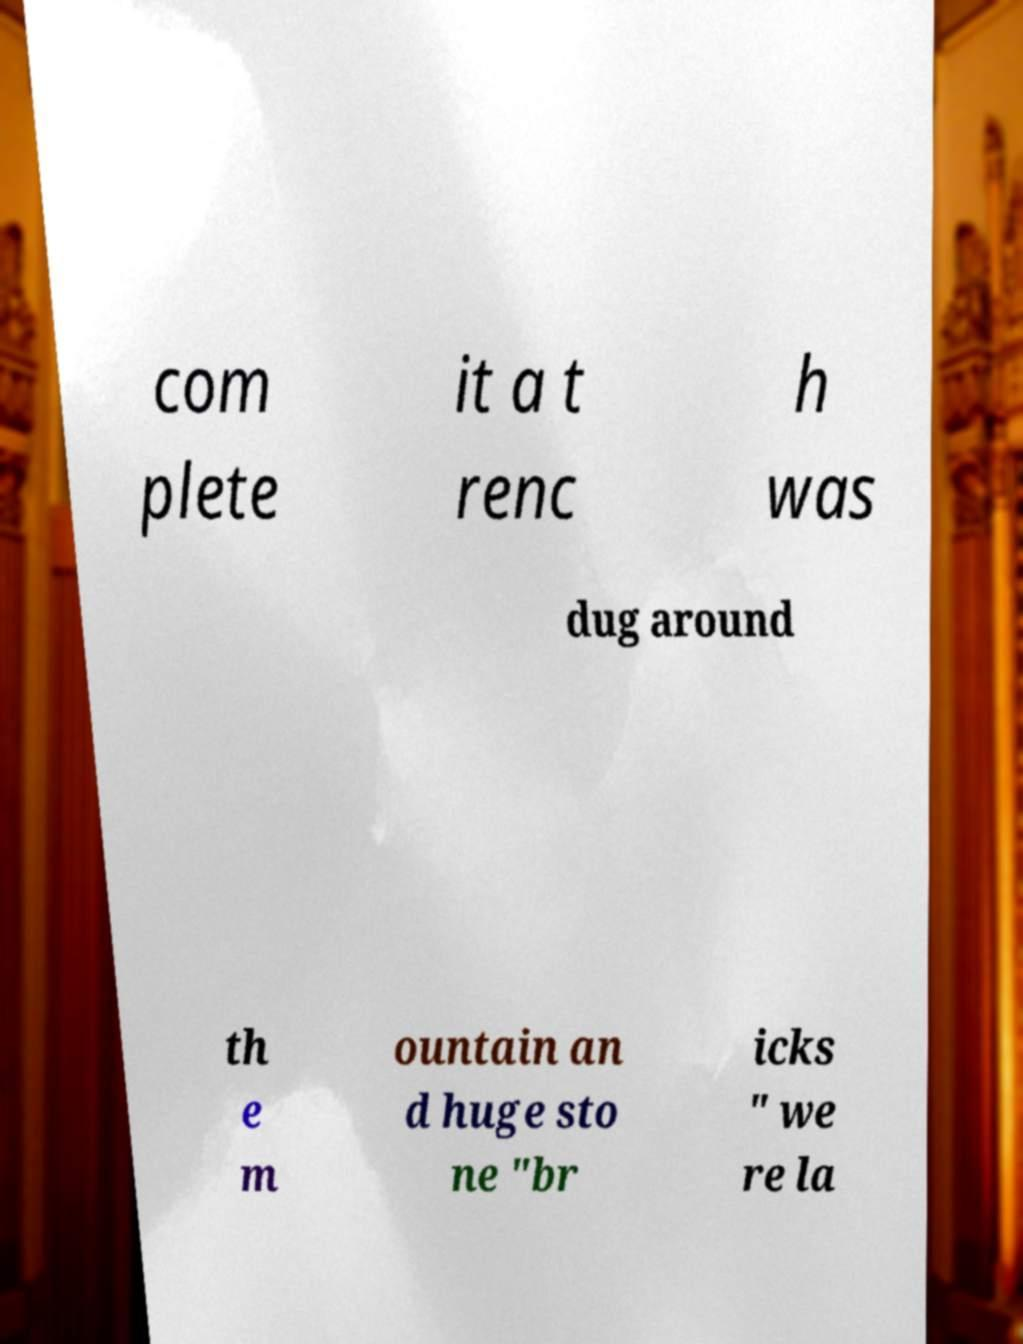There's text embedded in this image that I need extracted. Can you transcribe it verbatim? com plete it a t renc h was dug around th e m ountain an d huge sto ne "br icks " we re la 